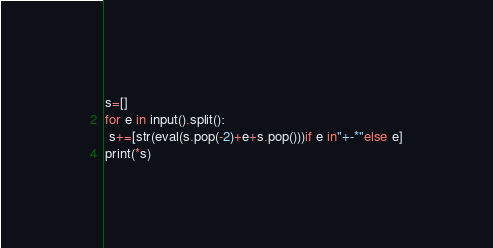Convert code to text. <code><loc_0><loc_0><loc_500><loc_500><_Python_>s=[]
for e in input().split():
 s+=[str(eval(s.pop(-2)+e+s.pop()))if e in"+-*"else e]
print(*s)
</code> 